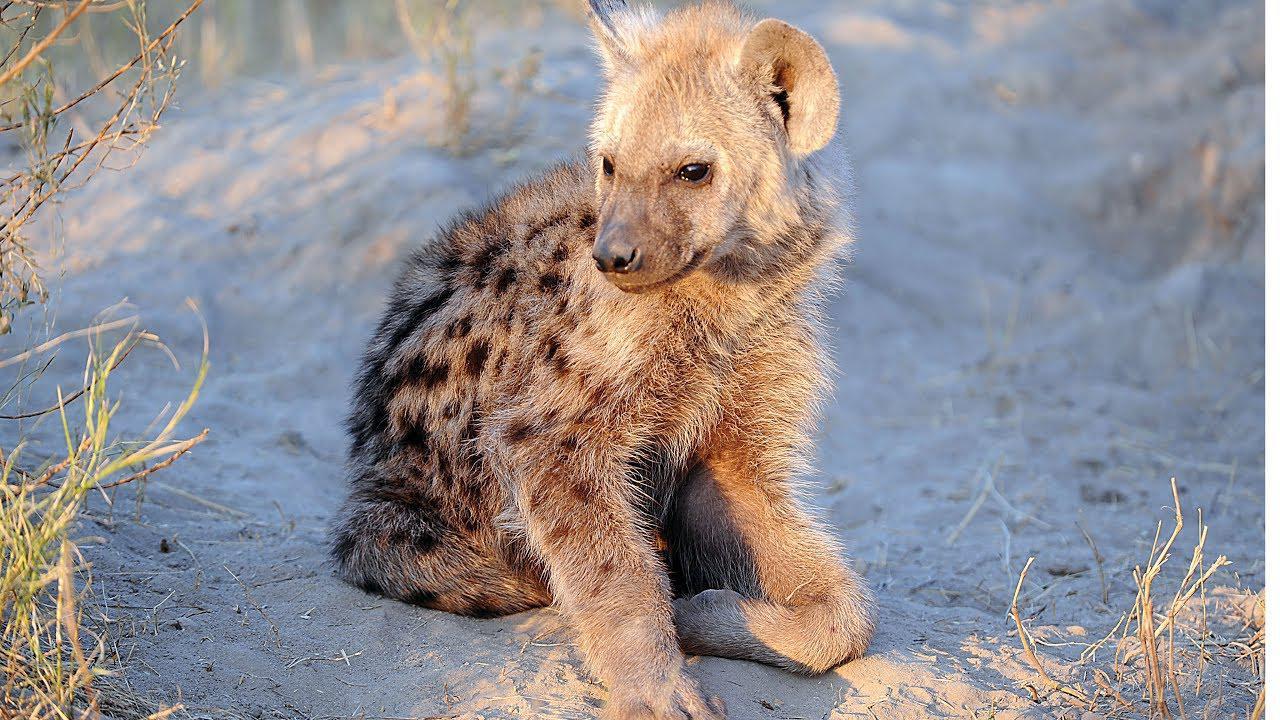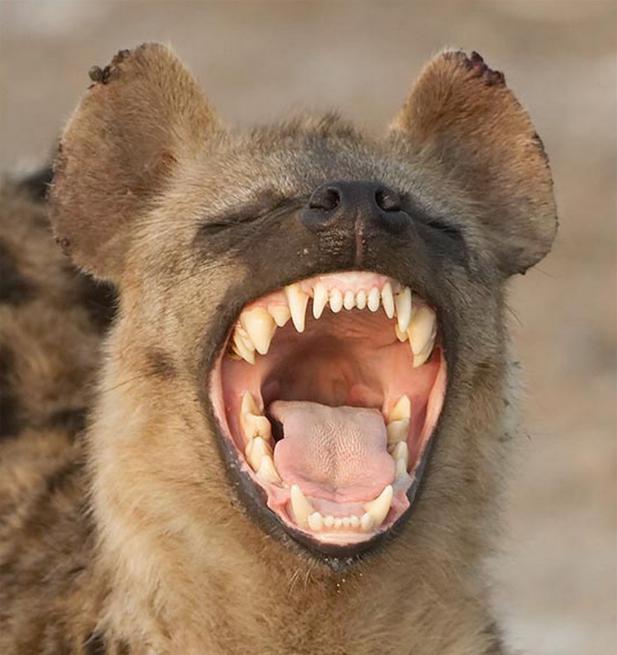The first image is the image on the left, the second image is the image on the right. Analyze the images presented: Is the assertion "Right image shows exactly one hyena, which is baring its fangs." valid? Answer yes or no. Yes. The first image is the image on the left, the second image is the image on the right. Evaluate the accuracy of this statement regarding the images: "Out of the two animals, one of them has its mouth wide open.". Is it true? Answer yes or no. Yes. 